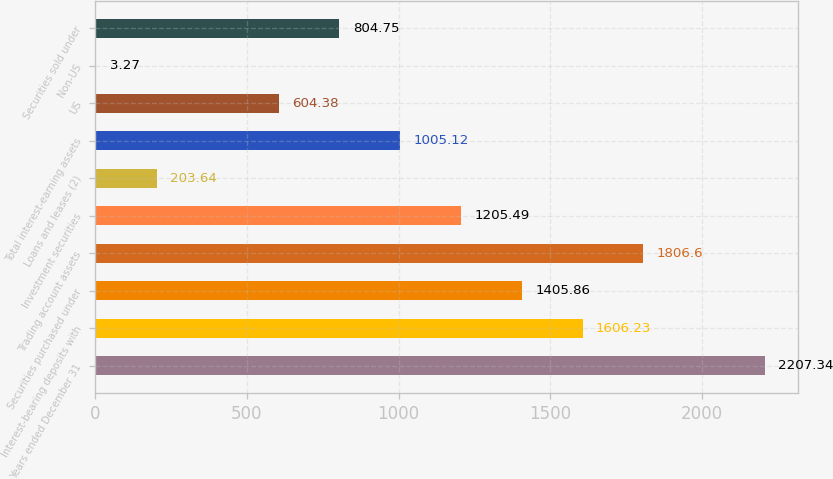<chart> <loc_0><loc_0><loc_500><loc_500><bar_chart><fcel>Years ended December 31<fcel>Interest-bearing deposits with<fcel>Securities purchased under<fcel>Trading account assets<fcel>Investment securities<fcel>Loans and leases (2)<fcel>Total interest-earning assets<fcel>US<fcel>Non-US<fcel>Securities sold under<nl><fcel>2207.34<fcel>1606.23<fcel>1405.86<fcel>1806.6<fcel>1205.49<fcel>203.64<fcel>1005.12<fcel>604.38<fcel>3.27<fcel>804.75<nl></chart> 